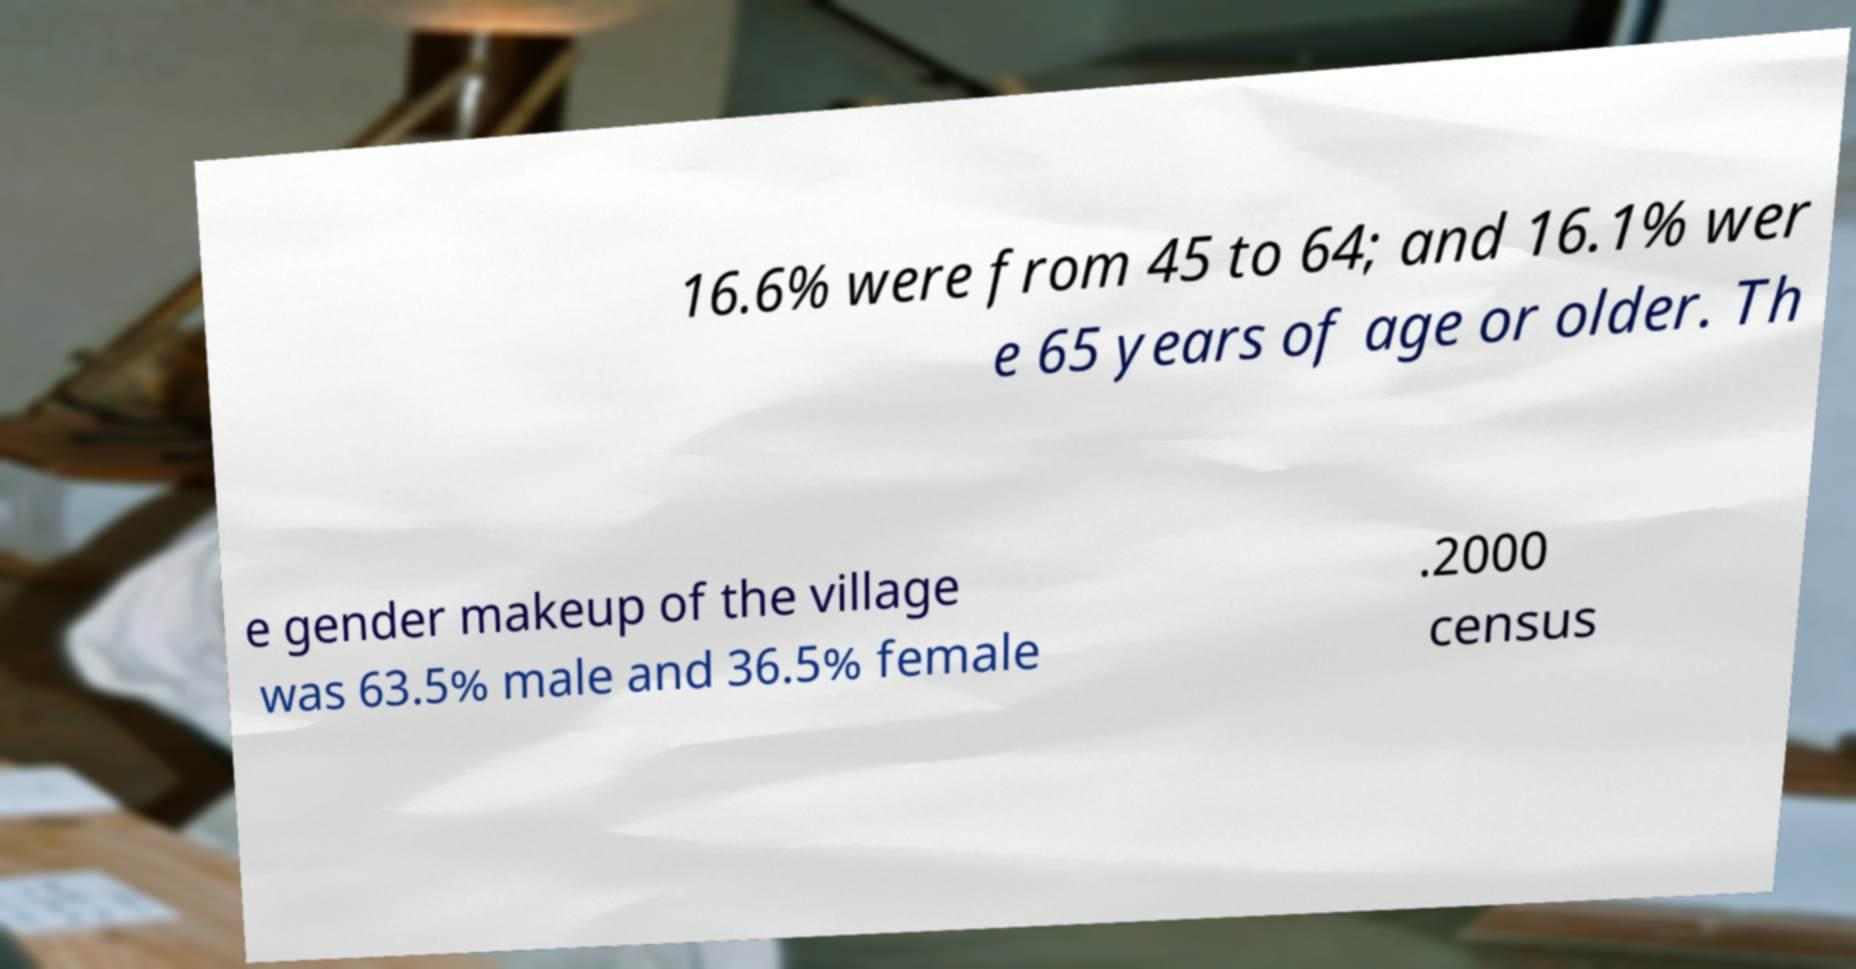Can you read and provide the text displayed in the image?This photo seems to have some interesting text. Can you extract and type it out for me? 16.6% were from 45 to 64; and 16.1% wer e 65 years of age or older. Th e gender makeup of the village was 63.5% male and 36.5% female .2000 census 